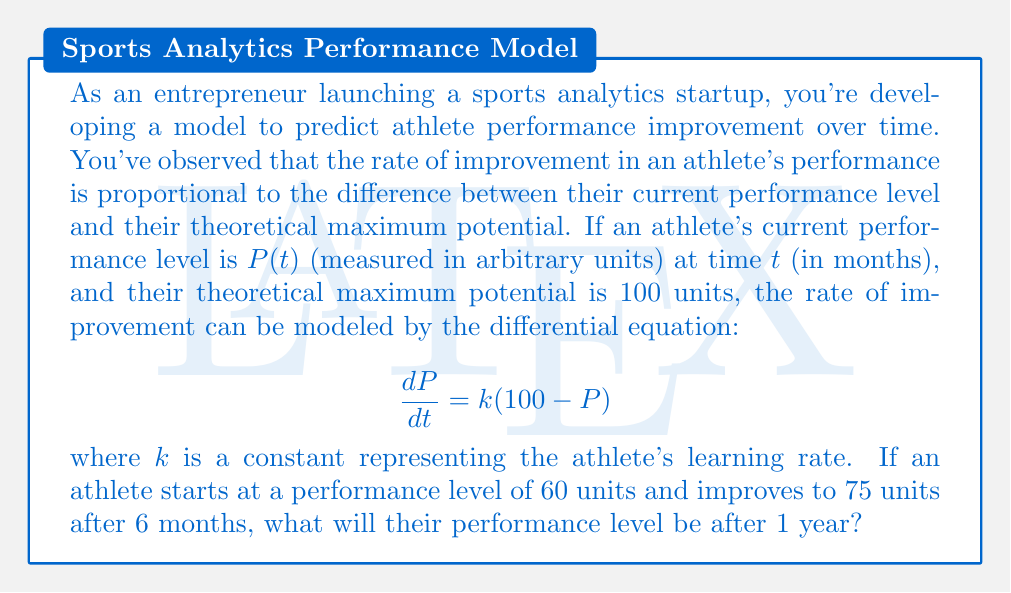Can you solve this math problem? Let's solve this problem step by step:

1) We're given the differential equation:
   $$\frac{dP}{dt} = k(100 - P)$$

2) This is a separable first-order differential equation. We can solve it as follows:
   $$\frac{dP}{100 - P} = k dt$$

3) Integrating both sides:
   $$-\ln|100 - P| = kt + C$$

4) Solving for P:
   $$P = 100 - Ae^{-kt}$$
   where $A$ is a constant of integration.

5) We're given that $P(0) = 60$, so:
   $$60 = 100 - A$$
   $$A = 40$$

6) Our solution is now:
   $$P = 100 - 40e^{-kt}$$

7) We're also told that $P(6) = 75$. Let's use this to find $k$:
   $$75 = 100 - 40e^{-6k}$$
   $$25 = 40e^{-6k}$$
   $$\frac{25}{40} = e^{-6k}$$
   $$\ln(\frac{25}{40}) = -6k$$
   $$k = -\frac{1}{6}\ln(\frac{25}{40}) \approx 0.0801$$

8) Now we have our complete solution:
   $$P = 100 - 40e^{-0.0801t}$$

9) To find the performance after 1 year (12 months), we substitute $t=12$:
   $$P(12) = 100 - 40e^{-0.0801(12)} \approx 83.7$$

Therefore, after 1 year, the athlete's performance level will be approximately 83.7 units.
Answer: 83.7 units 